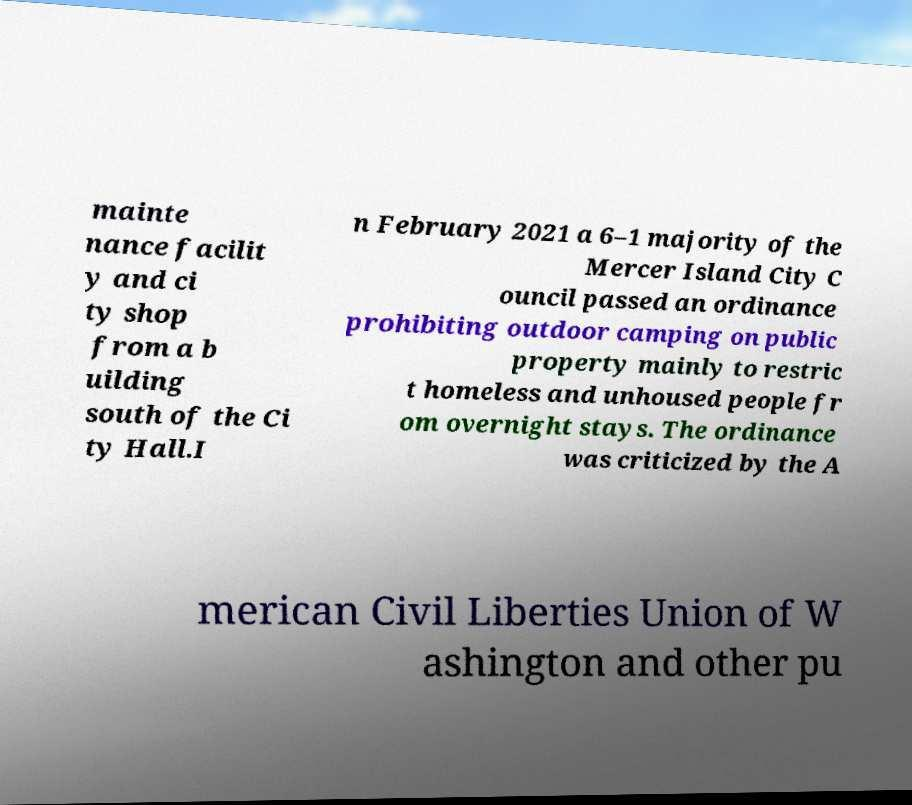Please read and relay the text visible in this image. What does it say? mainte nance facilit y and ci ty shop from a b uilding south of the Ci ty Hall.I n February 2021 a 6–1 majority of the Mercer Island City C ouncil passed an ordinance prohibiting outdoor camping on public property mainly to restric t homeless and unhoused people fr om overnight stays. The ordinance was criticized by the A merican Civil Liberties Union of W ashington and other pu 